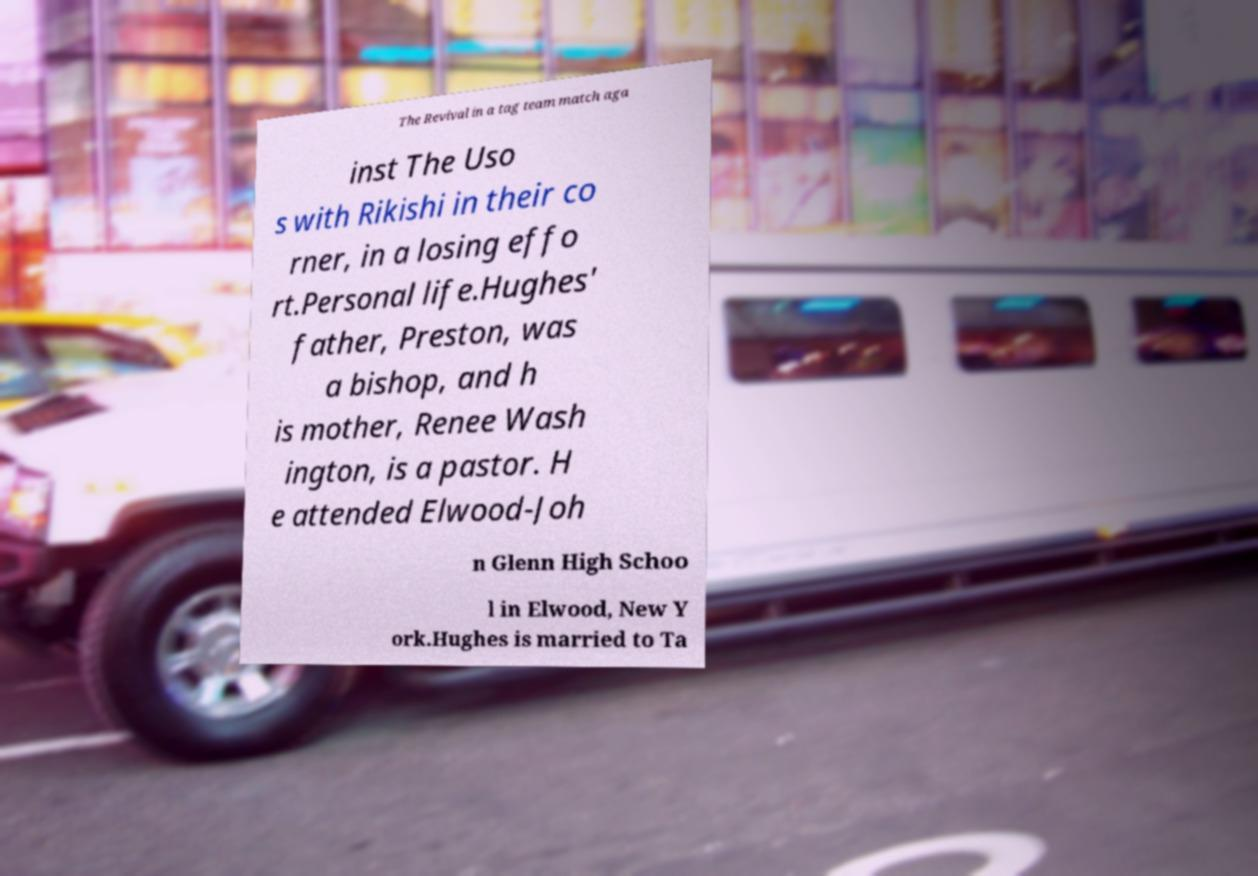Please identify and transcribe the text found in this image. The Revival in a tag team match aga inst The Uso s with Rikishi in their co rner, in a losing effo rt.Personal life.Hughes' father, Preston, was a bishop, and h is mother, Renee Wash ington, is a pastor. H e attended Elwood-Joh n Glenn High Schoo l in Elwood, New Y ork.Hughes is married to Ta 